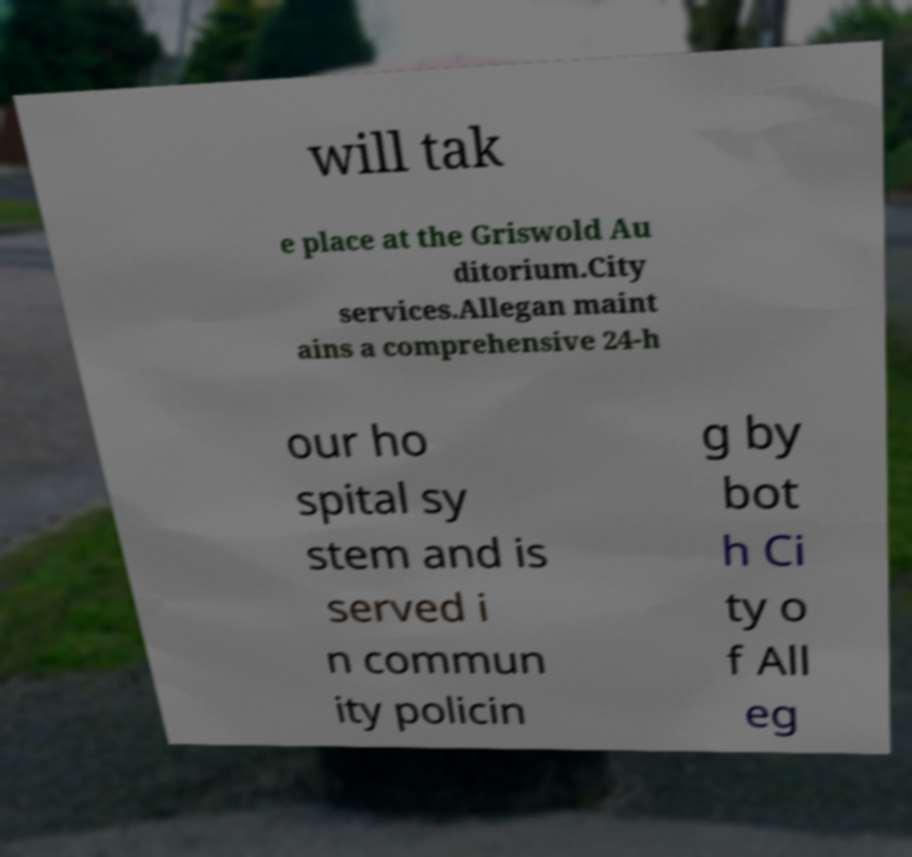I need the written content from this picture converted into text. Can you do that? will tak e place at the Griswold Au ditorium.City services.Allegan maint ains a comprehensive 24-h our ho spital sy stem and is served i n commun ity policin g by bot h Ci ty o f All eg 